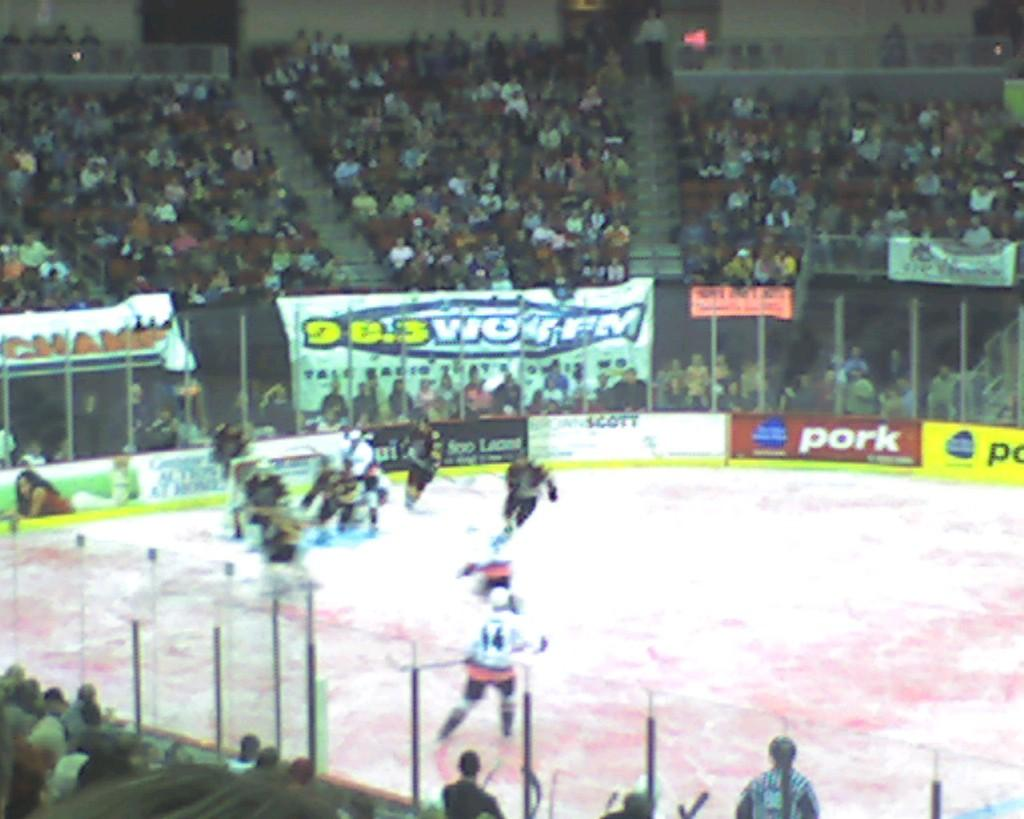Provide a one-sentence caption for the provided image. A fairly packed stadium at a hocky game with 98.3 WOR FM as a sponsor. 